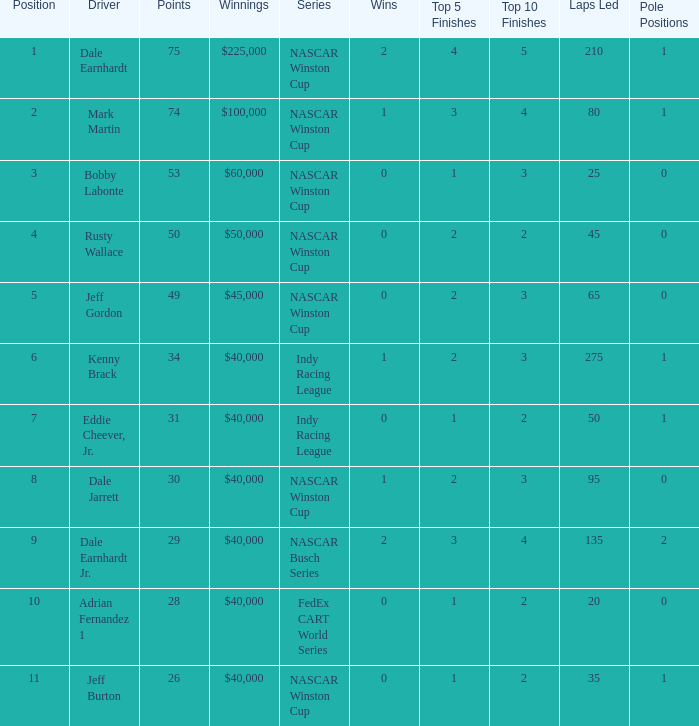In what position was the driver who won $60,000? 3.0. 